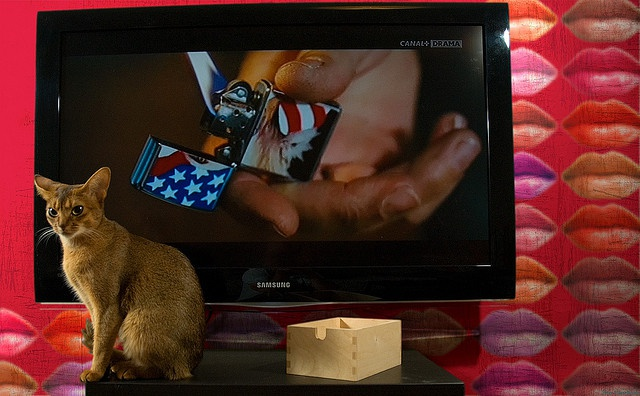Describe the objects in this image and their specific colors. I can see tv in brown, black, maroon, and gray tones, people in brown, maroon, and black tones, and cat in brown, maroon, black, and olive tones in this image. 